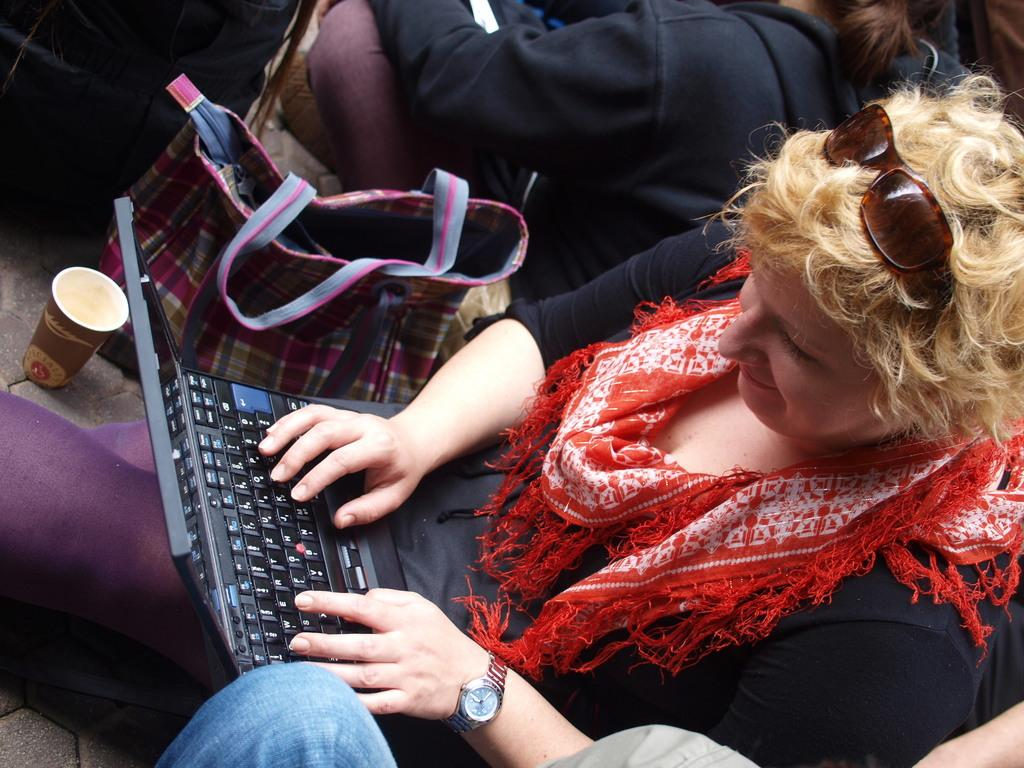Who or what can be seen in the image? There are people in the image. What electronic device is present in the image? There is a laptop in the image. What accessory is visible in the image? There is a handbag in the image. What is the people holding in the image? There is a cup in the image. Can you describe any other objects in the image? There are other unspecified objects in the image. What type of beast can be seen roaming in the image? There is no beast present in the image. How does the fog affect the visibility of the objects in the image? There is no fog present in the image; it is clear. 